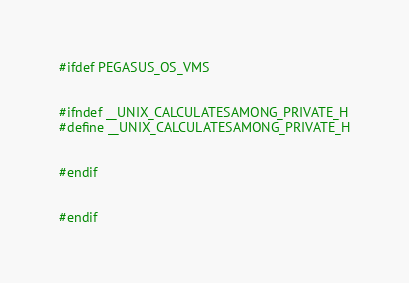Convert code to text. <code><loc_0><loc_0><loc_500><loc_500><_C++_>#ifdef PEGASUS_OS_VMS


#ifndef __UNIX_CALCULATESAMONG_PRIVATE_H
#define __UNIX_CALCULATESAMONG_PRIVATE_H


#endif


#endif
</code> 